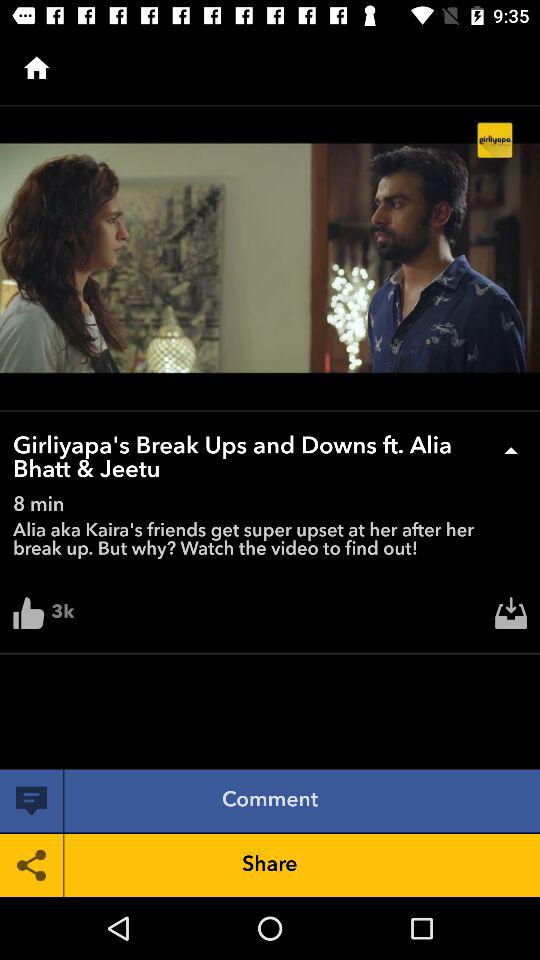How many minutes long is the video?
Answer the question using a single word or phrase. 8 